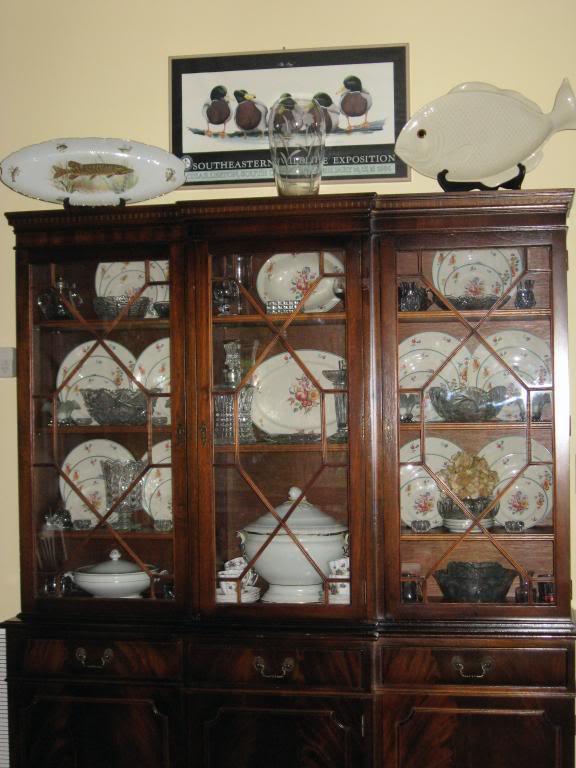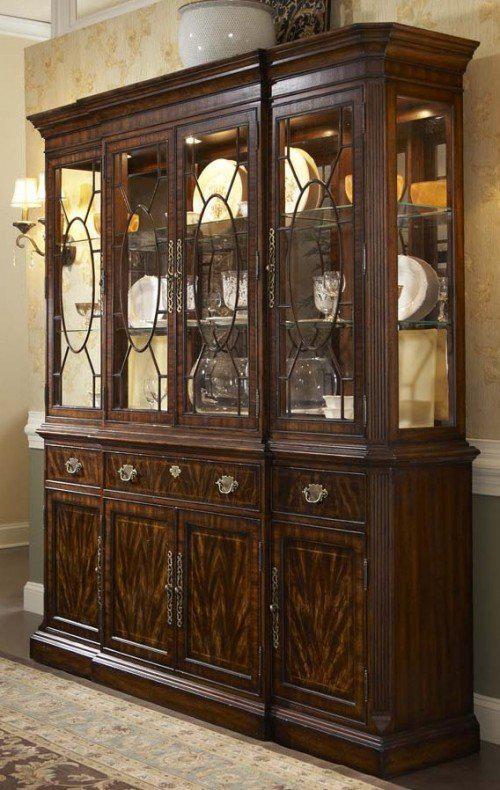The first image is the image on the left, the second image is the image on the right. For the images displayed, is the sentence "Blue and white patterned plates are displayed on the shelves of one china cabinet." factually correct? Answer yes or no. No. The first image is the image on the left, the second image is the image on the right. Considering the images on both sides, is "There are display items on top of at least one hutch" valid? Answer yes or no. Yes. 